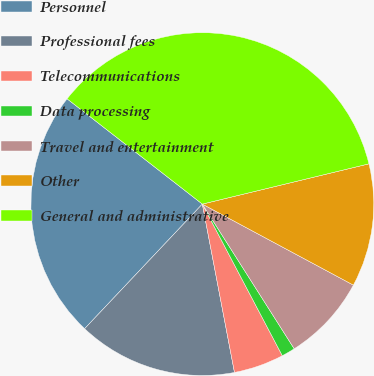<chart> <loc_0><loc_0><loc_500><loc_500><pie_chart><fcel>Personnel<fcel>Professional fees<fcel>Telecommunications<fcel>Data processing<fcel>Travel and entertainment<fcel>Other<fcel>General and administrative<nl><fcel>23.48%<fcel>15.05%<fcel>4.72%<fcel>1.28%<fcel>8.16%<fcel>11.61%<fcel>35.7%<nl></chart> 